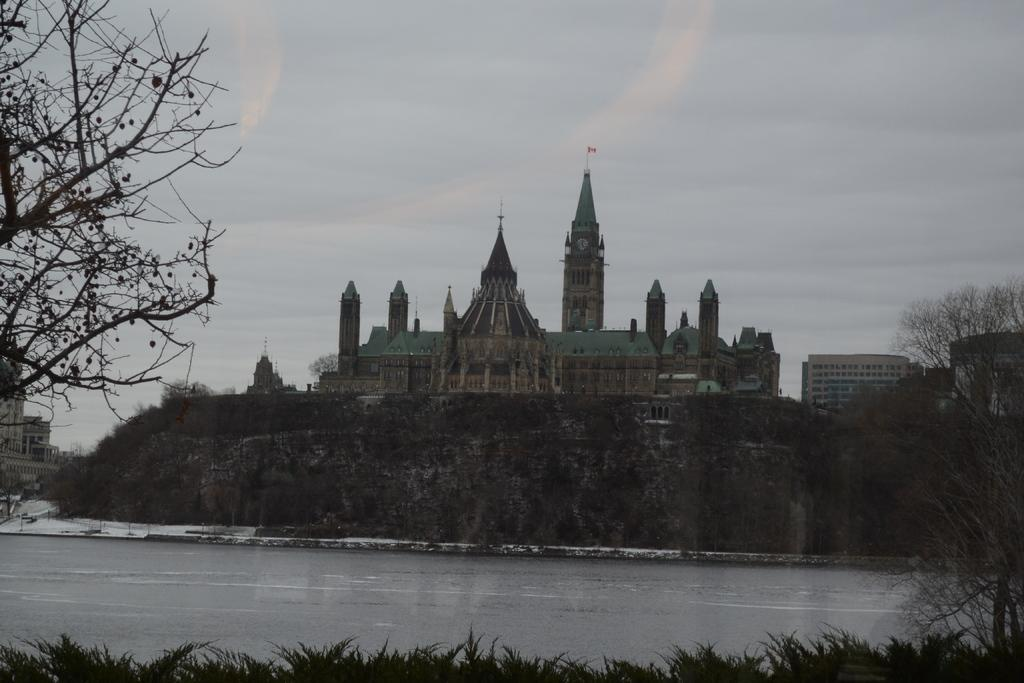What is the primary element present in the image? There is water in the image. What other natural elements can be seen in the image? There are trees in the image. Are there any man-made structures visible in the image? Yes, there are buildings in the image. What can be seen in the background of the image? There are clouds visible in the background of the image. How does the cat interact with the water in the image? There is no cat present in the image, so it cannot interact with the water. 